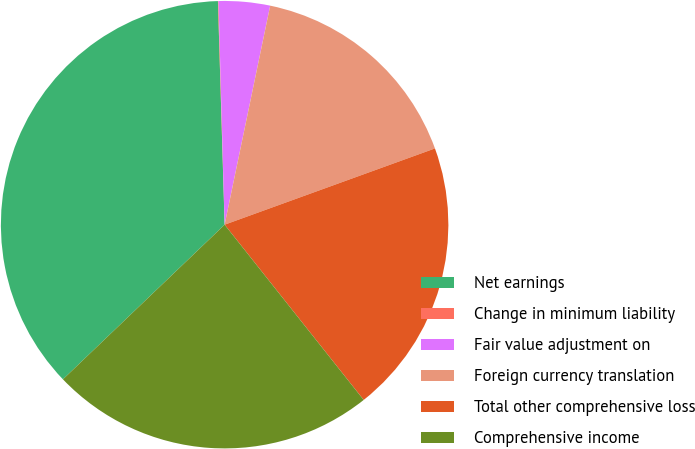<chart> <loc_0><loc_0><loc_500><loc_500><pie_chart><fcel>Net earnings<fcel>Change in minimum liability<fcel>Fair value adjustment on<fcel>Foreign currency translation<fcel>Total other comprehensive loss<fcel>Comprehensive income<nl><fcel>36.67%<fcel>0.04%<fcel>3.7%<fcel>16.2%<fcel>19.86%<fcel>23.53%<nl></chart> 